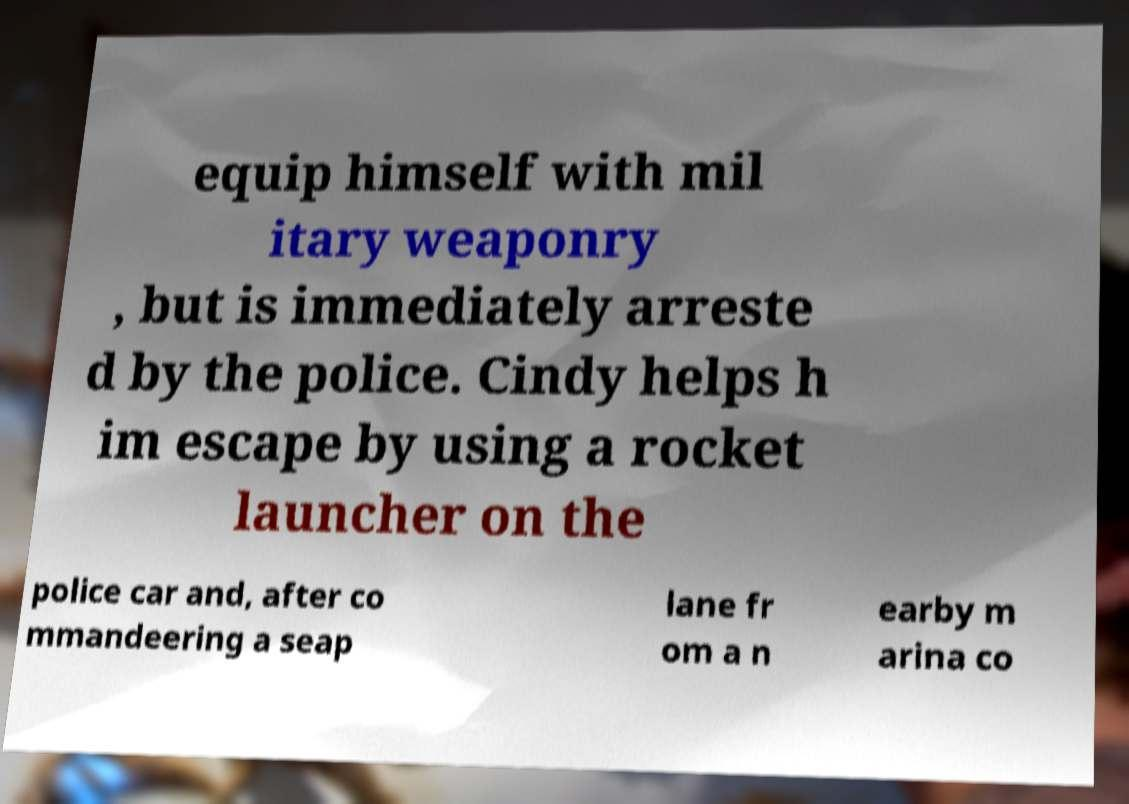Please read and relay the text visible in this image. What does it say? equip himself with mil itary weaponry , but is immediately arreste d by the police. Cindy helps h im escape by using a rocket launcher on the police car and, after co mmandeering a seap lane fr om a n earby m arina co 